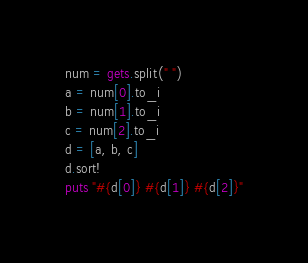Convert code to text. <code><loc_0><loc_0><loc_500><loc_500><_Ruby_>num = gets.split(" ")
a = num[0].to_i
b = num[1].to_i
c = num[2].to_i
d = [a, b, c]
d.sort!
puts "#{d[0]} #{d[1]} #{d[2]}"</code> 